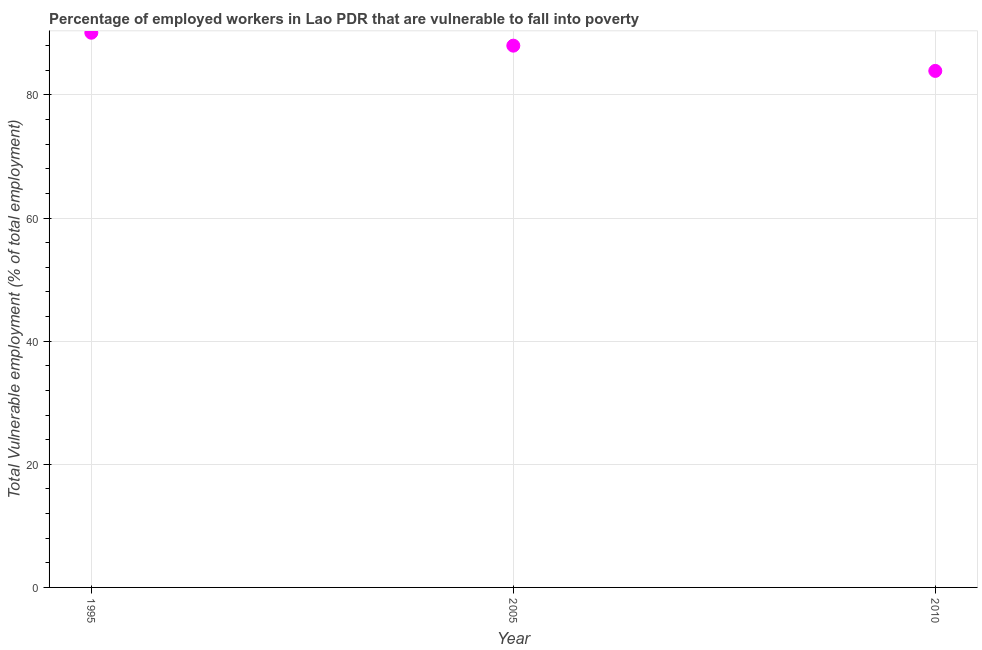What is the total vulnerable employment in 2005?
Offer a terse response. 88. Across all years, what is the maximum total vulnerable employment?
Make the answer very short. 90.1. Across all years, what is the minimum total vulnerable employment?
Provide a succinct answer. 83.9. In which year was the total vulnerable employment minimum?
Your answer should be very brief. 2010. What is the sum of the total vulnerable employment?
Provide a succinct answer. 262. What is the difference between the total vulnerable employment in 1995 and 2005?
Your response must be concise. 2.1. What is the average total vulnerable employment per year?
Make the answer very short. 87.33. What is the ratio of the total vulnerable employment in 1995 to that in 2005?
Offer a very short reply. 1.02. Is the difference between the total vulnerable employment in 1995 and 2005 greater than the difference between any two years?
Provide a succinct answer. No. What is the difference between the highest and the second highest total vulnerable employment?
Ensure brevity in your answer.  2.1. Is the sum of the total vulnerable employment in 1995 and 2005 greater than the maximum total vulnerable employment across all years?
Provide a short and direct response. Yes. What is the difference between the highest and the lowest total vulnerable employment?
Keep it short and to the point. 6.2. How many years are there in the graph?
Your answer should be compact. 3. Are the values on the major ticks of Y-axis written in scientific E-notation?
Provide a succinct answer. No. Does the graph contain any zero values?
Your answer should be compact. No. What is the title of the graph?
Offer a terse response. Percentage of employed workers in Lao PDR that are vulnerable to fall into poverty. What is the label or title of the X-axis?
Keep it short and to the point. Year. What is the label or title of the Y-axis?
Give a very brief answer. Total Vulnerable employment (% of total employment). What is the Total Vulnerable employment (% of total employment) in 1995?
Your response must be concise. 90.1. What is the Total Vulnerable employment (% of total employment) in 2005?
Give a very brief answer. 88. What is the Total Vulnerable employment (% of total employment) in 2010?
Give a very brief answer. 83.9. What is the difference between the Total Vulnerable employment (% of total employment) in 1995 and 2010?
Your response must be concise. 6.2. What is the difference between the Total Vulnerable employment (% of total employment) in 2005 and 2010?
Ensure brevity in your answer.  4.1. What is the ratio of the Total Vulnerable employment (% of total employment) in 1995 to that in 2010?
Your answer should be very brief. 1.07. What is the ratio of the Total Vulnerable employment (% of total employment) in 2005 to that in 2010?
Provide a short and direct response. 1.05. 